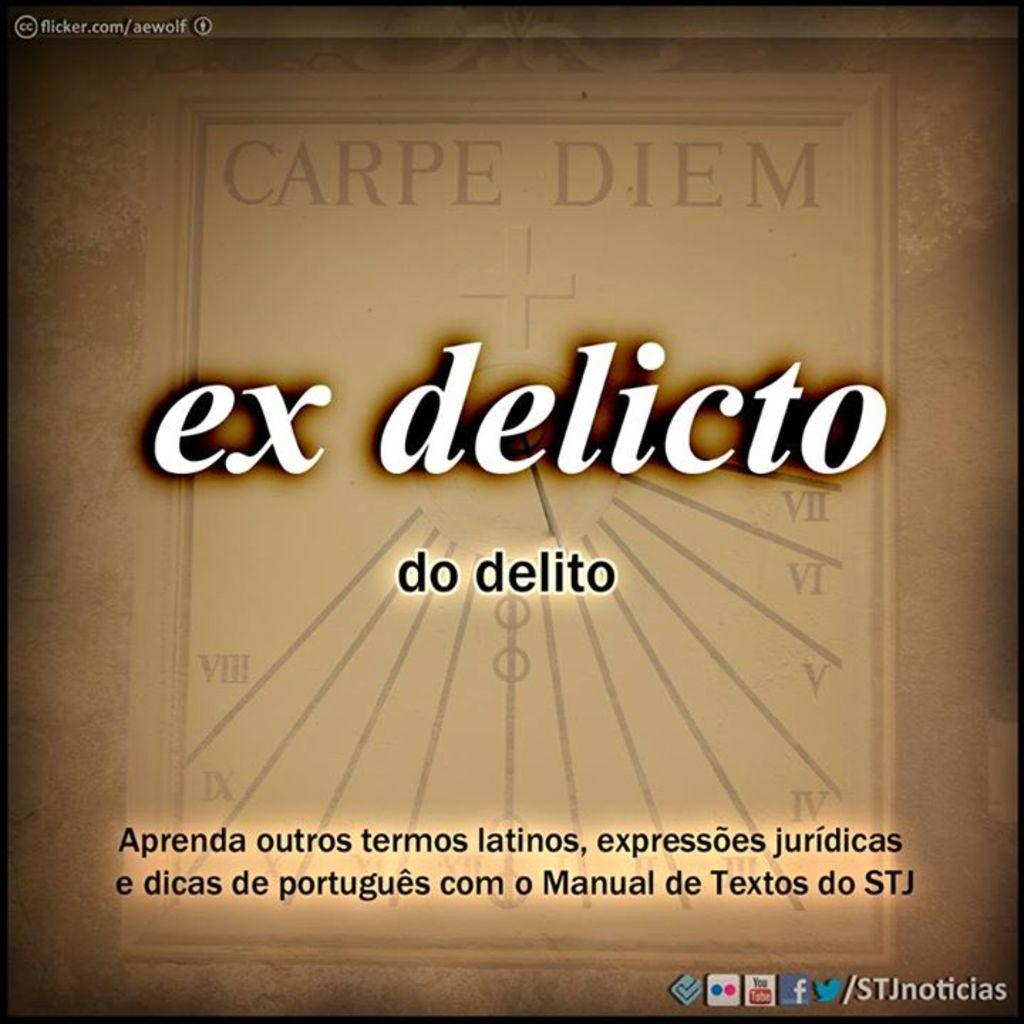<image>
Describe the image concisely. A CD cover titled Carpe Diem ex delicto do delito. 